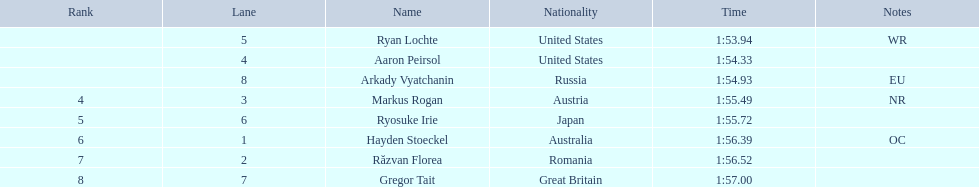Who participated in the event? Ryan Lochte, Aaron Peirsol, Arkady Vyatchanin, Markus Rogan, Ryosuke Irie, Hayden Stoeckel, Răzvan Florea, Gregor Tait. What was the finishing time of each athlete? 1:53.94, 1:54.33, 1:54.93, 1:55.49, 1:55.72, 1:56.39, 1:56.52, 1:57.00. How about just ryosuke irie? 1:55.72. Who were the participants in the event? Ryan Lochte, Aaron Peirsol, Arkady Vyatchanin, Markus Rogan, Ryosuke Irie, Hayden Stoeckel, Răzvan Florea, Gregor Tait. What were the completion times for each athlete? 1:53.94, 1:54.33, 1:54.93, 1:55.49, 1:55.72, 1:56.39, 1:56.52, 1:57.00. Can you provide details on just ryosuke irie's performance? 1:55.72. 